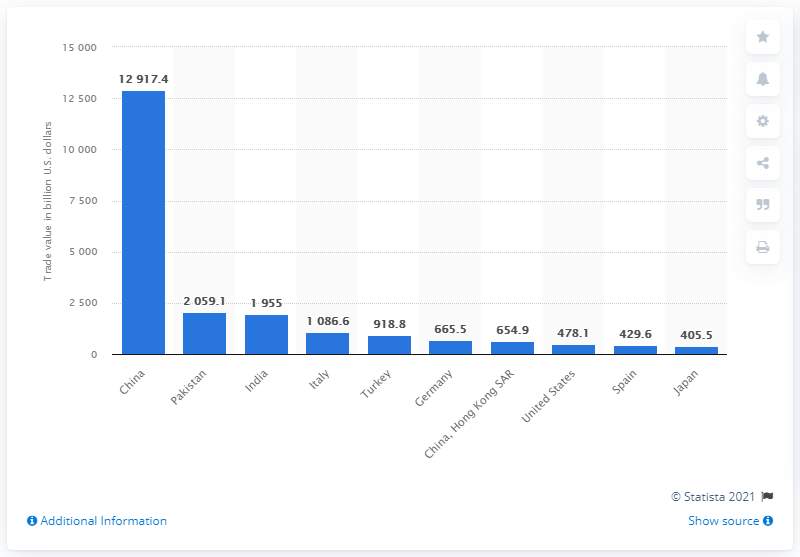Specify some key components in this picture. The value of Pakistan's woven cotton fabric exported to the rest of the world in 2019 was 2059.1 million US dollars. China is the leading export country. The total of Spain and Japan is 835.1... In 2019, China exported a total of 129,174.4 metric tons of woven cotton fabric to other countries. 